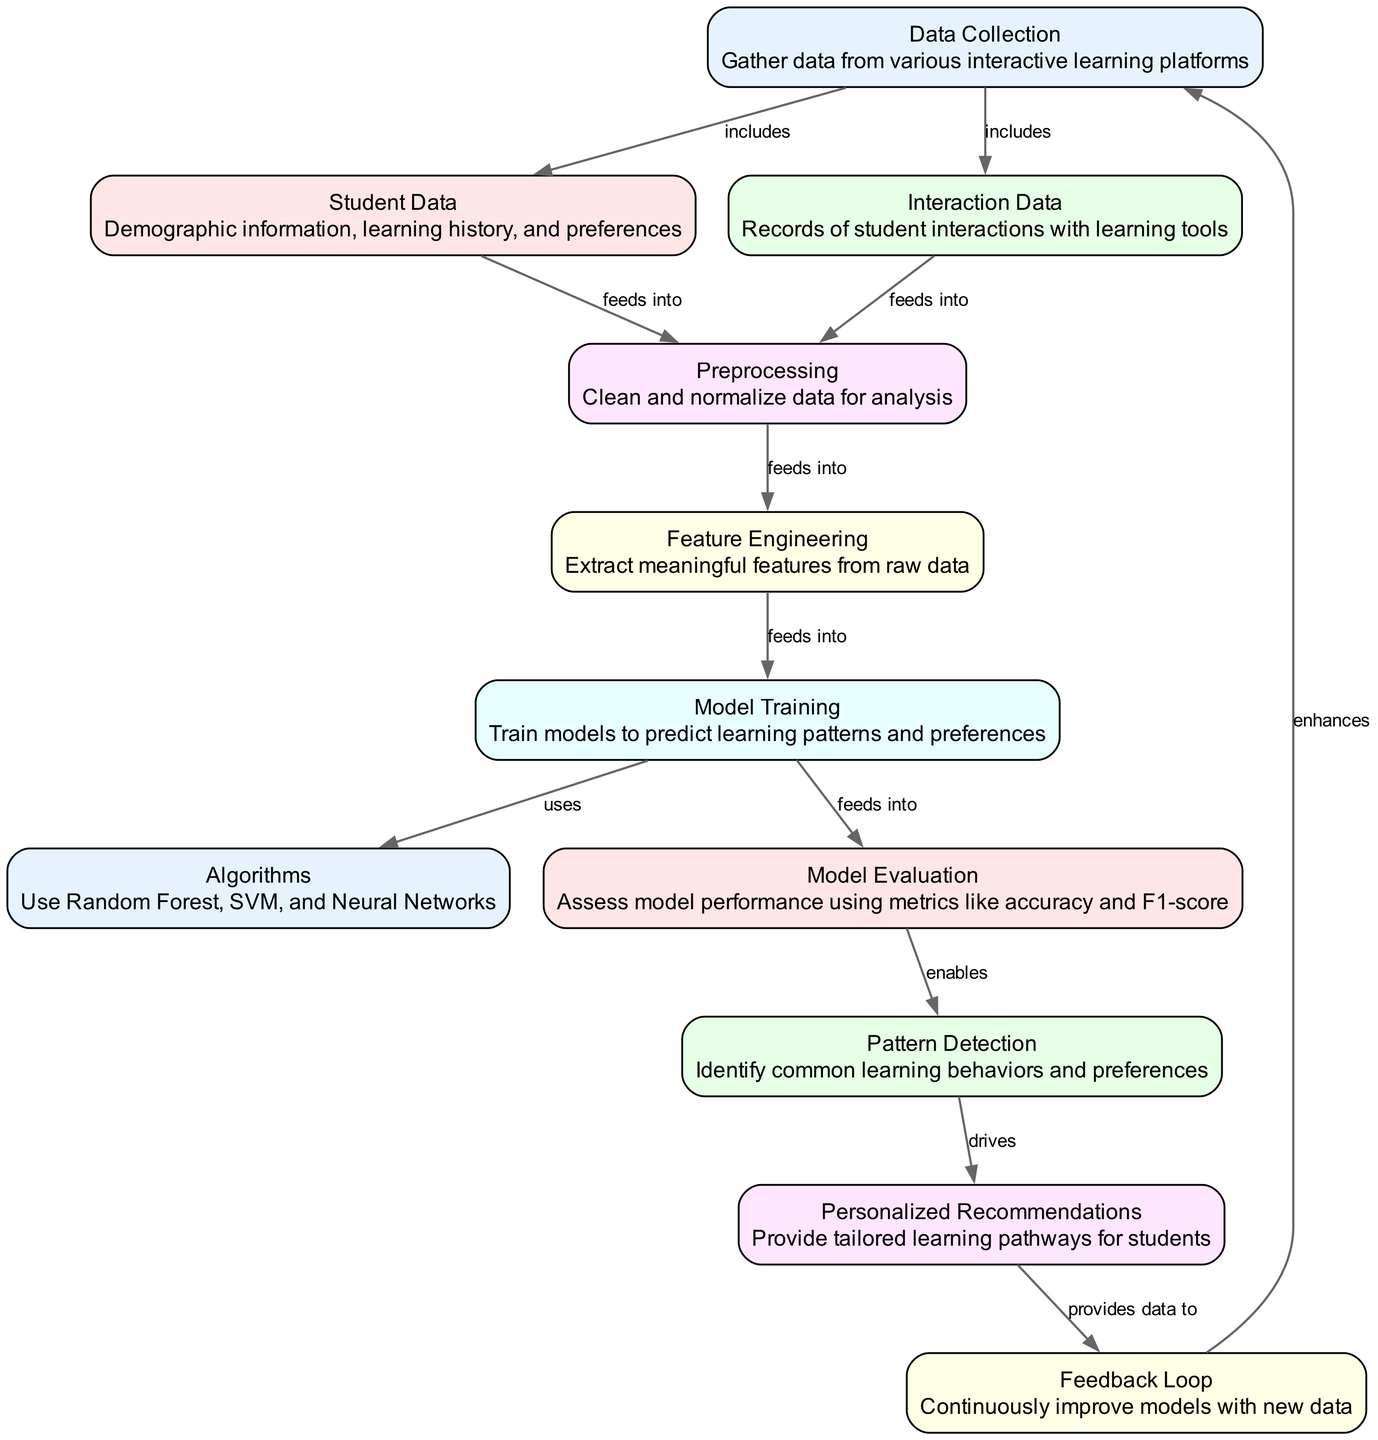What is the first step in the diagram? The first step in the diagram is "Data Collection." This is indicated as the initial node from which other processes originate.
Answer: Data Collection How many nodes are present in the diagram? There are a total of 11 nodes displayed in the diagram, each representing different components of the predictive model process.
Answer: 11 Which node feeds into model training? The node that feeds into "Model Training" is "Feature Engineering." This is shown by the directed edge connecting these two nodes.
Answer: Feature Engineering What algorithms are used in the model training process? The algorithms mentioned in the diagram for model training are Random Forest, SVM, and Neural Networks, clearly listed in the "Algorithms" node.
Answer: Random Forest, SVM, Neural Networks How does the model evaluation influence pattern detection? The "Model Evaluation" node enables "Pattern Detection." This means that assessing the performance of the models helps identify common learning behaviors and preferences.
Answer: Enables Which node provides data to the feedback loop? The node that provides data to the "Feedback Loop" is "Personalized Recommendations." This relationship is indicated by the directed edge from "Personalized Recommendations" to "Feedback Loop."
Answer: Personalized Recommendations What is the primary purpose of the feedback loop? The primary purpose of the "Feedback Loop" is to enhance the "Data Collection" process. This indicates that new data helps improve the overall system continuously.
Answer: Enhances What type of metrics are used for model evaluation? The metrics used for "Model Evaluation" include accuracy and F1-score. This information is explicitly mentioned in the description of the "Model Evaluation" node.
Answer: Accuracy and F1-score Which step of the process involves cleaning and normalizing data? The step that involves cleaning and normalizing data is "Preprocessing." This is essential for preparing data for further analysis.
Answer: Preprocessing 